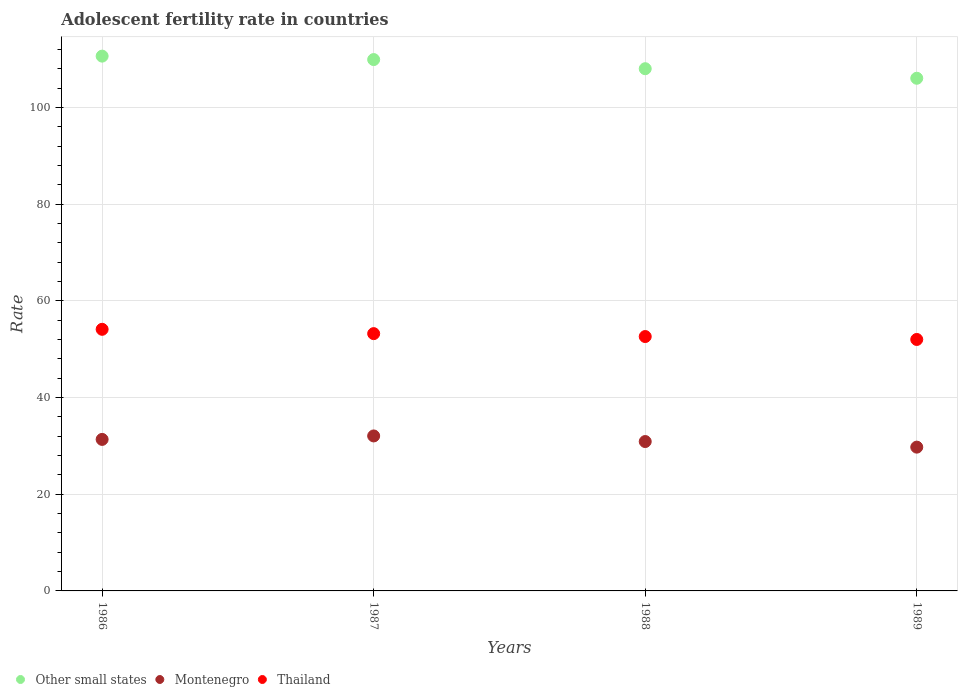How many different coloured dotlines are there?
Offer a terse response. 3. Is the number of dotlines equal to the number of legend labels?
Provide a succinct answer. Yes. What is the adolescent fertility rate in Montenegro in 1986?
Your response must be concise. 31.35. Across all years, what is the maximum adolescent fertility rate in Thailand?
Offer a terse response. 54.13. Across all years, what is the minimum adolescent fertility rate in Thailand?
Provide a short and direct response. 52.03. In which year was the adolescent fertility rate in Thailand maximum?
Keep it short and to the point. 1986. In which year was the adolescent fertility rate in Montenegro minimum?
Offer a terse response. 1989. What is the total adolescent fertility rate in Other small states in the graph?
Offer a terse response. 434.76. What is the difference between the adolescent fertility rate in Thailand in 1988 and that in 1989?
Your response must be concise. 0.6. What is the difference between the adolescent fertility rate in Thailand in 1988 and the adolescent fertility rate in Montenegro in 1989?
Your response must be concise. 22.88. What is the average adolescent fertility rate in Montenegro per year?
Offer a terse response. 31.02. In the year 1989, what is the difference between the adolescent fertility rate in Montenegro and adolescent fertility rate in Other small states?
Offer a very short reply. -76.33. What is the ratio of the adolescent fertility rate in Other small states in 1986 to that in 1988?
Keep it short and to the point. 1.02. What is the difference between the highest and the second highest adolescent fertility rate in Thailand?
Your answer should be compact. 0.89. What is the difference between the highest and the lowest adolescent fertility rate in Other small states?
Your answer should be very brief. 4.58. Does the adolescent fertility rate in Montenegro monotonically increase over the years?
Ensure brevity in your answer.  No. Is the adolescent fertility rate in Montenegro strictly less than the adolescent fertility rate in Other small states over the years?
Provide a succinct answer. Yes. How many dotlines are there?
Give a very brief answer. 3. How many years are there in the graph?
Provide a succinct answer. 4. What is the difference between two consecutive major ticks on the Y-axis?
Ensure brevity in your answer.  20. Does the graph contain grids?
Offer a terse response. Yes. Where does the legend appear in the graph?
Ensure brevity in your answer.  Bottom left. How many legend labels are there?
Ensure brevity in your answer.  3. How are the legend labels stacked?
Keep it short and to the point. Horizontal. What is the title of the graph?
Offer a very short reply. Adolescent fertility rate in countries. What is the label or title of the X-axis?
Your response must be concise. Years. What is the label or title of the Y-axis?
Your response must be concise. Rate. What is the Rate in Other small states in 1986?
Offer a terse response. 110.66. What is the Rate in Montenegro in 1986?
Your response must be concise. 31.35. What is the Rate of Thailand in 1986?
Provide a short and direct response. 54.13. What is the Rate in Other small states in 1987?
Give a very brief answer. 109.95. What is the Rate in Montenegro in 1987?
Ensure brevity in your answer.  32.07. What is the Rate in Thailand in 1987?
Your answer should be very brief. 53.24. What is the Rate of Other small states in 1988?
Keep it short and to the point. 108.06. What is the Rate in Montenegro in 1988?
Offer a terse response. 30.91. What is the Rate in Thailand in 1988?
Your answer should be very brief. 52.64. What is the Rate of Other small states in 1989?
Your response must be concise. 106.08. What is the Rate of Montenegro in 1989?
Your answer should be compact. 29.75. What is the Rate of Thailand in 1989?
Make the answer very short. 52.03. Across all years, what is the maximum Rate in Other small states?
Provide a short and direct response. 110.66. Across all years, what is the maximum Rate in Montenegro?
Your answer should be very brief. 32.07. Across all years, what is the maximum Rate of Thailand?
Your answer should be compact. 54.13. Across all years, what is the minimum Rate of Other small states?
Your response must be concise. 106.08. Across all years, what is the minimum Rate in Montenegro?
Your answer should be compact. 29.75. Across all years, what is the minimum Rate of Thailand?
Your answer should be very brief. 52.03. What is the total Rate of Other small states in the graph?
Offer a terse response. 434.76. What is the total Rate in Montenegro in the graph?
Offer a terse response. 124.09. What is the total Rate in Thailand in the graph?
Ensure brevity in your answer.  212.04. What is the difference between the Rate in Other small states in 1986 and that in 1987?
Ensure brevity in your answer.  0.71. What is the difference between the Rate in Montenegro in 1986 and that in 1987?
Offer a very short reply. -0.72. What is the difference between the Rate of Thailand in 1986 and that in 1987?
Give a very brief answer. 0.89. What is the difference between the Rate in Other small states in 1986 and that in 1988?
Offer a very short reply. 2.6. What is the difference between the Rate of Montenegro in 1986 and that in 1988?
Provide a succinct answer. 0.44. What is the difference between the Rate in Thailand in 1986 and that in 1988?
Make the answer very short. 1.5. What is the difference between the Rate in Other small states in 1986 and that in 1989?
Provide a succinct answer. 4.58. What is the difference between the Rate of Montenegro in 1986 and that in 1989?
Give a very brief answer. 1.6. What is the difference between the Rate of Other small states in 1987 and that in 1988?
Keep it short and to the point. 1.89. What is the difference between the Rate in Montenegro in 1987 and that in 1988?
Make the answer very short. 1.16. What is the difference between the Rate of Thailand in 1987 and that in 1988?
Your response must be concise. 0.6. What is the difference between the Rate of Other small states in 1987 and that in 1989?
Offer a terse response. 3.87. What is the difference between the Rate of Montenegro in 1987 and that in 1989?
Your answer should be compact. 2.32. What is the difference between the Rate in Thailand in 1987 and that in 1989?
Make the answer very short. 1.21. What is the difference between the Rate in Other small states in 1988 and that in 1989?
Your response must be concise. 1.98. What is the difference between the Rate of Montenegro in 1988 and that in 1989?
Make the answer very short. 1.16. What is the difference between the Rate of Thailand in 1988 and that in 1989?
Make the answer very short. 0.6. What is the difference between the Rate of Other small states in 1986 and the Rate of Montenegro in 1987?
Give a very brief answer. 78.59. What is the difference between the Rate of Other small states in 1986 and the Rate of Thailand in 1987?
Your response must be concise. 57.42. What is the difference between the Rate in Montenegro in 1986 and the Rate in Thailand in 1987?
Ensure brevity in your answer.  -21.89. What is the difference between the Rate in Other small states in 1986 and the Rate in Montenegro in 1988?
Offer a very short reply. 79.75. What is the difference between the Rate of Other small states in 1986 and the Rate of Thailand in 1988?
Offer a terse response. 58.03. What is the difference between the Rate of Montenegro in 1986 and the Rate of Thailand in 1988?
Your answer should be compact. -21.28. What is the difference between the Rate of Other small states in 1986 and the Rate of Montenegro in 1989?
Keep it short and to the point. 80.91. What is the difference between the Rate of Other small states in 1986 and the Rate of Thailand in 1989?
Give a very brief answer. 58.63. What is the difference between the Rate of Montenegro in 1986 and the Rate of Thailand in 1989?
Your answer should be compact. -20.68. What is the difference between the Rate of Other small states in 1987 and the Rate of Montenegro in 1988?
Your answer should be compact. 79.04. What is the difference between the Rate of Other small states in 1987 and the Rate of Thailand in 1988?
Ensure brevity in your answer.  57.31. What is the difference between the Rate in Montenegro in 1987 and the Rate in Thailand in 1988?
Give a very brief answer. -20.57. What is the difference between the Rate of Other small states in 1987 and the Rate of Montenegro in 1989?
Make the answer very short. 80.2. What is the difference between the Rate of Other small states in 1987 and the Rate of Thailand in 1989?
Provide a succinct answer. 57.92. What is the difference between the Rate in Montenegro in 1987 and the Rate in Thailand in 1989?
Your answer should be very brief. -19.96. What is the difference between the Rate of Other small states in 1988 and the Rate of Montenegro in 1989?
Your answer should be very brief. 78.31. What is the difference between the Rate of Other small states in 1988 and the Rate of Thailand in 1989?
Keep it short and to the point. 56.03. What is the difference between the Rate in Montenegro in 1988 and the Rate in Thailand in 1989?
Make the answer very short. -21.12. What is the average Rate in Other small states per year?
Keep it short and to the point. 108.69. What is the average Rate in Montenegro per year?
Your response must be concise. 31.02. What is the average Rate in Thailand per year?
Offer a very short reply. 53.01. In the year 1986, what is the difference between the Rate in Other small states and Rate in Montenegro?
Your answer should be compact. 79.31. In the year 1986, what is the difference between the Rate of Other small states and Rate of Thailand?
Give a very brief answer. 56.53. In the year 1986, what is the difference between the Rate in Montenegro and Rate in Thailand?
Keep it short and to the point. -22.78. In the year 1987, what is the difference between the Rate in Other small states and Rate in Montenegro?
Give a very brief answer. 77.88. In the year 1987, what is the difference between the Rate in Other small states and Rate in Thailand?
Provide a succinct answer. 56.71. In the year 1987, what is the difference between the Rate of Montenegro and Rate of Thailand?
Make the answer very short. -21.17. In the year 1988, what is the difference between the Rate of Other small states and Rate of Montenegro?
Make the answer very short. 77.15. In the year 1988, what is the difference between the Rate of Other small states and Rate of Thailand?
Make the answer very short. 55.42. In the year 1988, what is the difference between the Rate in Montenegro and Rate in Thailand?
Make the answer very short. -21.73. In the year 1989, what is the difference between the Rate in Other small states and Rate in Montenegro?
Provide a short and direct response. 76.33. In the year 1989, what is the difference between the Rate of Other small states and Rate of Thailand?
Offer a terse response. 54.05. In the year 1989, what is the difference between the Rate of Montenegro and Rate of Thailand?
Your answer should be very brief. -22.28. What is the ratio of the Rate in Other small states in 1986 to that in 1987?
Make the answer very short. 1.01. What is the ratio of the Rate in Montenegro in 1986 to that in 1987?
Give a very brief answer. 0.98. What is the ratio of the Rate in Thailand in 1986 to that in 1987?
Provide a succinct answer. 1.02. What is the ratio of the Rate in Other small states in 1986 to that in 1988?
Give a very brief answer. 1.02. What is the ratio of the Rate in Montenegro in 1986 to that in 1988?
Provide a short and direct response. 1.01. What is the ratio of the Rate of Thailand in 1986 to that in 1988?
Provide a succinct answer. 1.03. What is the ratio of the Rate of Other small states in 1986 to that in 1989?
Provide a short and direct response. 1.04. What is the ratio of the Rate in Montenegro in 1986 to that in 1989?
Your answer should be very brief. 1.05. What is the ratio of the Rate of Thailand in 1986 to that in 1989?
Offer a terse response. 1.04. What is the ratio of the Rate in Other small states in 1987 to that in 1988?
Provide a succinct answer. 1.02. What is the ratio of the Rate of Montenegro in 1987 to that in 1988?
Your answer should be compact. 1.04. What is the ratio of the Rate in Thailand in 1987 to that in 1988?
Offer a very short reply. 1.01. What is the ratio of the Rate of Other small states in 1987 to that in 1989?
Your answer should be very brief. 1.04. What is the ratio of the Rate in Montenegro in 1987 to that in 1989?
Give a very brief answer. 1.08. What is the ratio of the Rate in Thailand in 1987 to that in 1989?
Your response must be concise. 1.02. What is the ratio of the Rate in Other small states in 1988 to that in 1989?
Give a very brief answer. 1.02. What is the ratio of the Rate of Montenegro in 1988 to that in 1989?
Provide a short and direct response. 1.04. What is the ratio of the Rate of Thailand in 1988 to that in 1989?
Offer a very short reply. 1.01. What is the difference between the highest and the second highest Rate of Other small states?
Make the answer very short. 0.71. What is the difference between the highest and the second highest Rate of Montenegro?
Ensure brevity in your answer.  0.72. What is the difference between the highest and the second highest Rate of Thailand?
Make the answer very short. 0.89. What is the difference between the highest and the lowest Rate in Other small states?
Provide a succinct answer. 4.58. What is the difference between the highest and the lowest Rate of Montenegro?
Give a very brief answer. 2.32. 